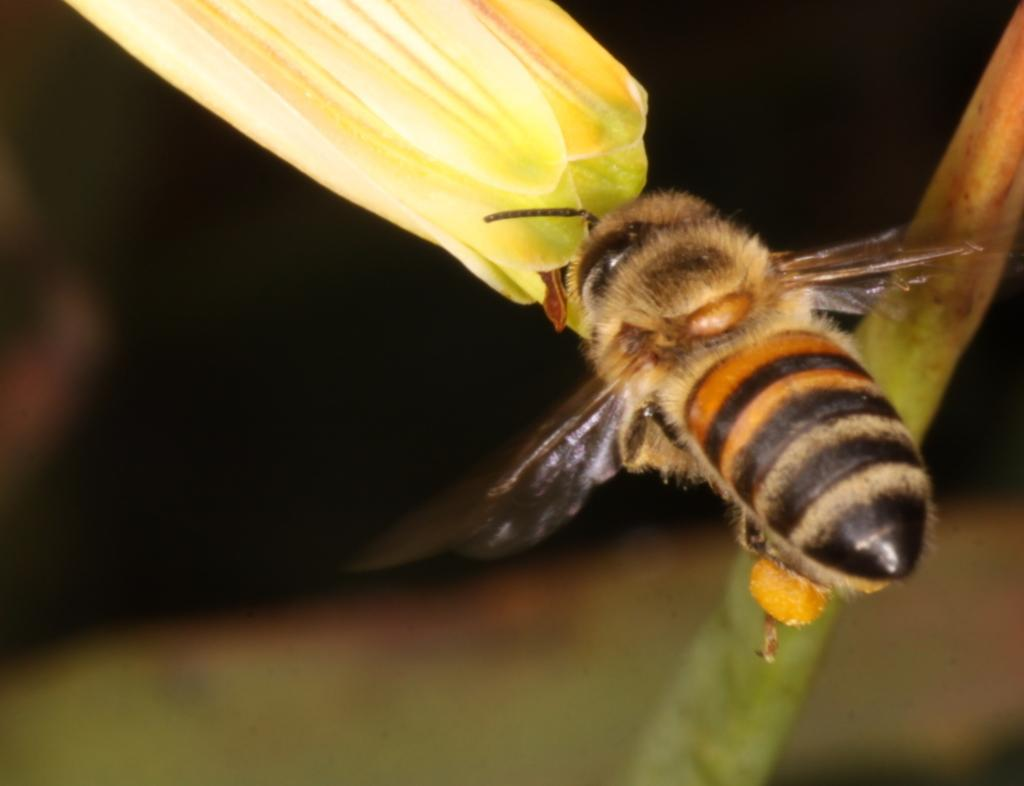What is located in the foreground of the image? There is an insect in the foreground of the image. What is the insect doing in the image? The insect is flying in the air. What is the insect flying near in the image? The insect is near a flower. What can be seen in the background of the image? There is a stem visible in the background of the image. How is the background of the image depicted? The background has a blurred image around the stem. What type of organization is depicted in the image? There is no organization present in the image; it features an insect flying near a flower. Can you tell me how many bridges are visible in the image? There are no bridges present in the image. 